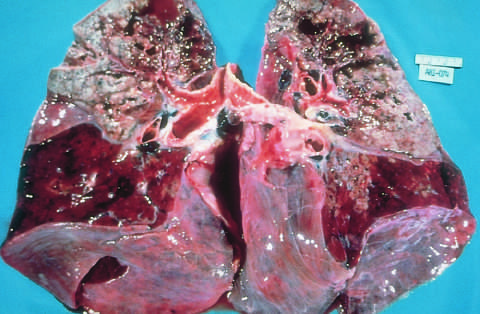re the segregation of b cells and t cells in different regions of the lymph node riddled with gray-white areas of caseation and multiple areas of softening and cavitation?
Answer the question using a single word or phrase. No 